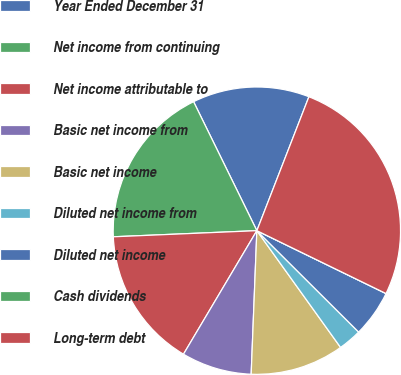<chart> <loc_0><loc_0><loc_500><loc_500><pie_chart><fcel>Year Ended December 31<fcel>Net income from continuing<fcel>Net income attributable to<fcel>Basic net income from<fcel>Basic net income<fcel>Diluted net income from<fcel>Diluted net income<fcel>Cash dividends<fcel>Long-term debt<nl><fcel>13.16%<fcel>18.42%<fcel>15.79%<fcel>7.9%<fcel>10.53%<fcel>2.63%<fcel>5.26%<fcel>0.0%<fcel>26.31%<nl></chart> 